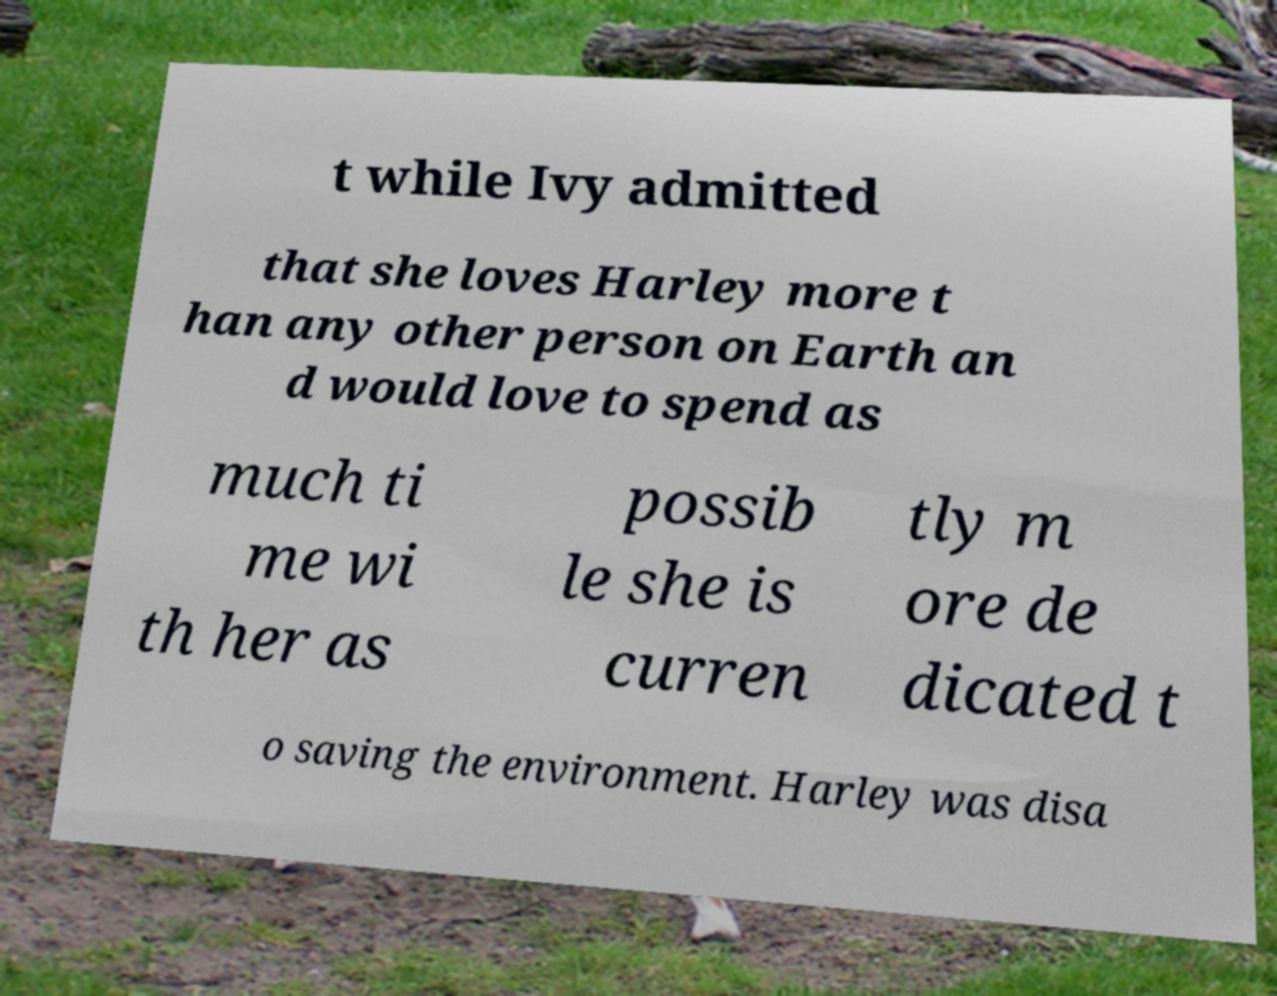What messages or text are displayed in this image? I need them in a readable, typed format. t while Ivy admitted that she loves Harley more t han any other person on Earth an d would love to spend as much ti me wi th her as possib le she is curren tly m ore de dicated t o saving the environment. Harley was disa 